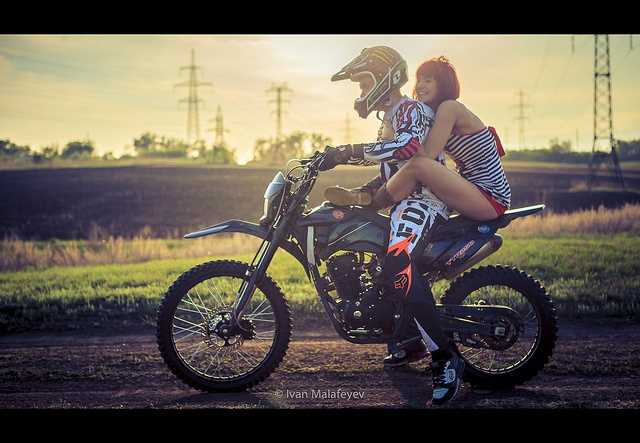Describe the objects in this image and their specific colors. I can see motorcycle in black and gray tones, people in black, gray, and tan tones, and people in black and gray tones in this image. 